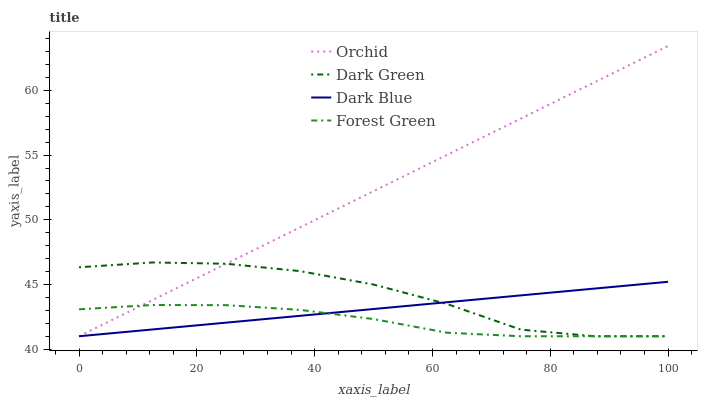Does Forest Green have the minimum area under the curve?
Answer yes or no. Yes. Does Orchid have the maximum area under the curve?
Answer yes or no. Yes. Does Dark Green have the minimum area under the curve?
Answer yes or no. No. Does Dark Green have the maximum area under the curve?
Answer yes or no. No. Is Dark Blue the smoothest?
Answer yes or no. Yes. Is Dark Green the roughest?
Answer yes or no. Yes. Is Forest Green the smoothest?
Answer yes or no. No. Is Forest Green the roughest?
Answer yes or no. No. Does Dark Blue have the lowest value?
Answer yes or no. Yes. Does Orchid have the highest value?
Answer yes or no. Yes. Does Dark Green have the highest value?
Answer yes or no. No. Does Orchid intersect Forest Green?
Answer yes or no. Yes. Is Orchid less than Forest Green?
Answer yes or no. No. Is Orchid greater than Forest Green?
Answer yes or no. No. 